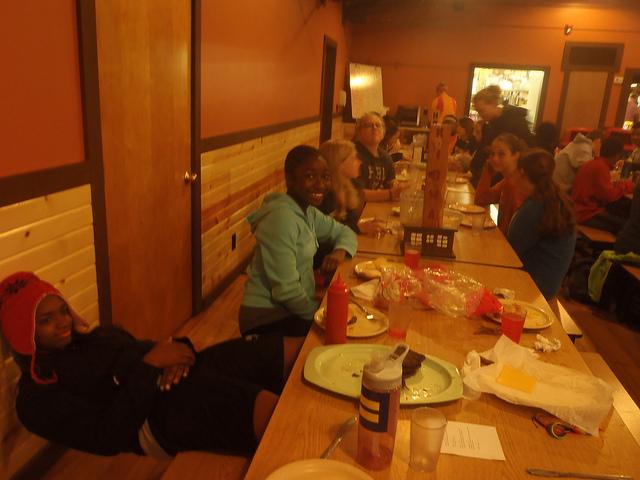Is there a beer can on the table?
Give a very brief answer. No. Where is the equal sign?
Give a very brief answer. Water bottle. How many of these people are female?
Keep it brief. 6. Are these people happy?
Concise answer only. Yes. What food is on the table?
Keep it brief. Cake. 